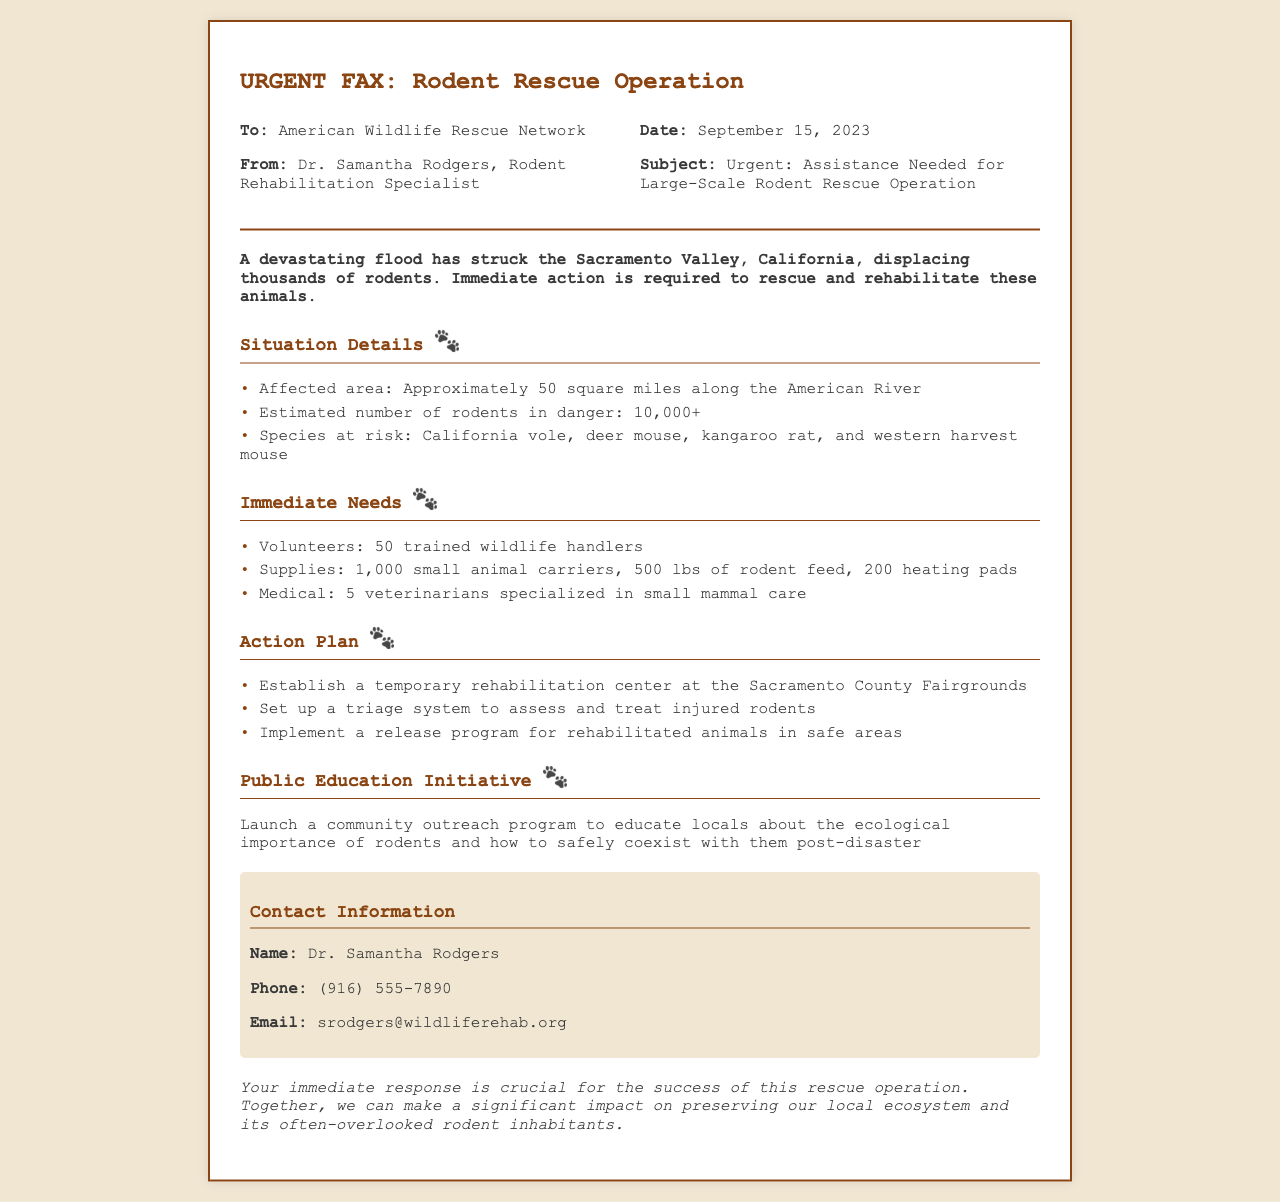what is the date of the fax? The date is specified in the header section of the fax as September 15, 2023.
Answer: September 15, 2023 who is the sender of the fax? The sender's name is listed in the header of the fax as Dr. Samantha Rodgers.
Answer: Dr. Samantha Rodgers how many rodents are estimated to be in danger? The document provides an estimate of the number of rodents affected by the flood, which is mentioned as 10,000+.
Answer: 10,000+ what is one species mentioned at risk? The fax lists multiple species at risk, and one example provided is the California vole.
Answer: California vole how many volunteers are needed? The document specifies that 50 trained wildlife handlers are required for the rescue operation.
Answer: 50 what is the primary purpose of the public education initiative? The document highlights the aim of the initiative is to educate locals about the ecological importance of rodents and coexisting with them.
Answer: Educate locals where will the temporary rehabilitation center be established? The fax states that the rehabilitation center will be set up at the Sacramento County Fairgrounds.
Answer: Sacramento County Fairgrounds how many veterinarians are needed for the operation? The fax mentions that 5 veterinarians specialized in small mammal care are required for the rescue effort.
Answer: 5 what is the affected area size? The document details that the affected area is approximately 50 square miles along the American River.
Answer: 50 square miles 